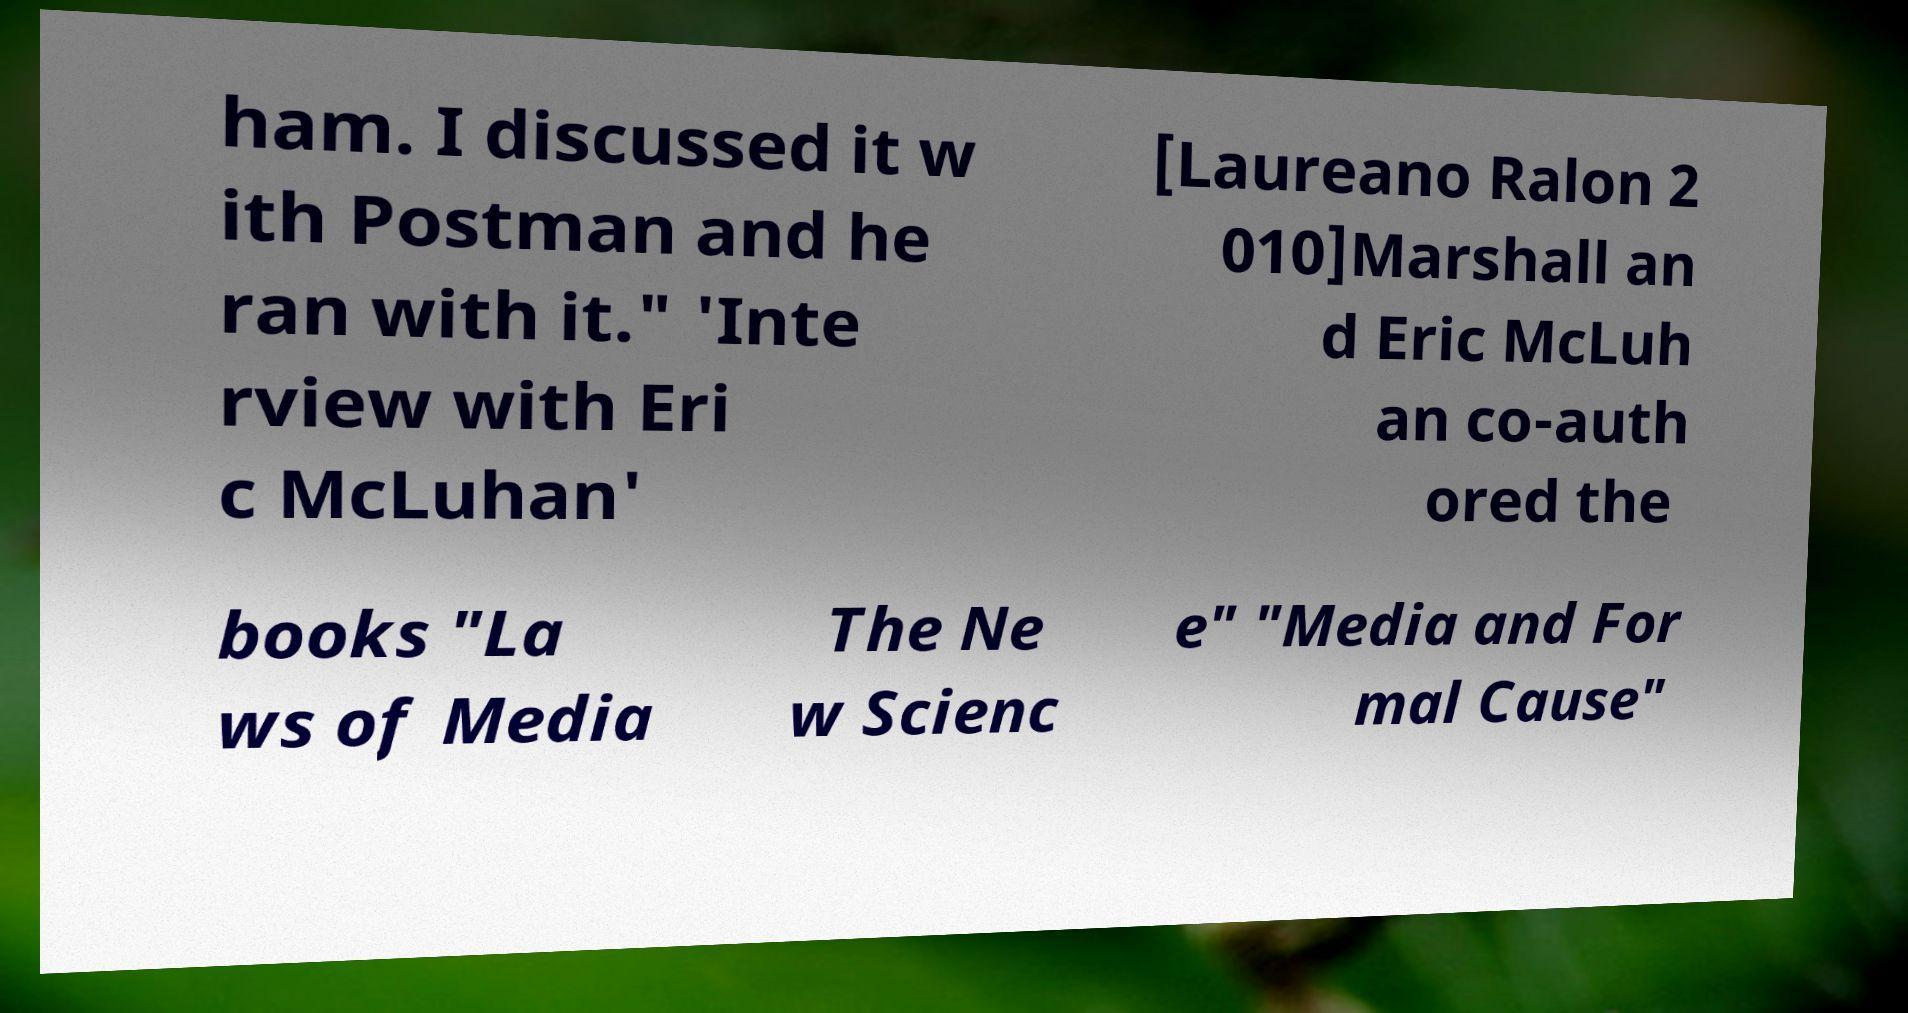Please read and relay the text visible in this image. What does it say? ham. I discussed it w ith Postman and he ran with it." 'Inte rview with Eri c McLuhan' [Laureano Ralon 2 010]Marshall an d Eric McLuh an co-auth ored the books "La ws of Media The Ne w Scienc e" "Media and For mal Cause" 